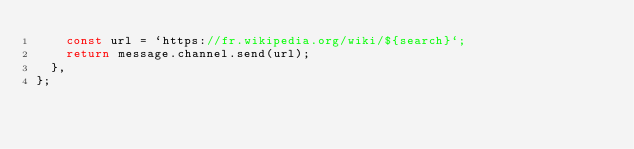<code> <loc_0><loc_0><loc_500><loc_500><_JavaScript_>    const url = `https://fr.wikipedia.org/wiki/${search}`;
    return message.channel.send(url);
  },
};
</code> 